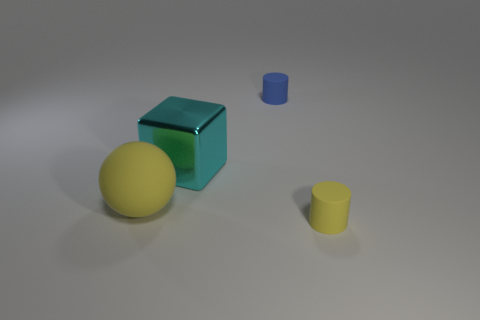Add 1 large shiny things. How many objects exist? 5 Subtract all cubes. How many objects are left? 3 Add 3 blue matte cylinders. How many blue matte cylinders exist? 4 Subtract 0 red balls. How many objects are left? 4 Subtract all small blue rubber cylinders. Subtract all large yellow objects. How many objects are left? 2 Add 1 shiny objects. How many shiny objects are left? 2 